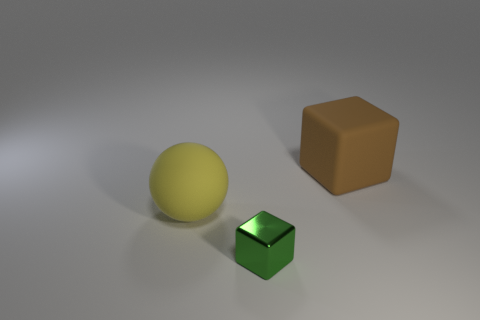Add 2 spheres. How many objects exist? 5 Subtract 0 gray cylinders. How many objects are left? 3 Subtract all cubes. How many objects are left? 1 Subtract 1 blocks. How many blocks are left? 1 Subtract all red balls. Subtract all gray cubes. How many balls are left? 1 Subtract all red spheres. How many cyan blocks are left? 0 Subtract all big rubber things. Subtract all large blocks. How many objects are left? 0 Add 1 small green cubes. How many small green cubes are left? 2 Add 3 brown cubes. How many brown cubes exist? 4 